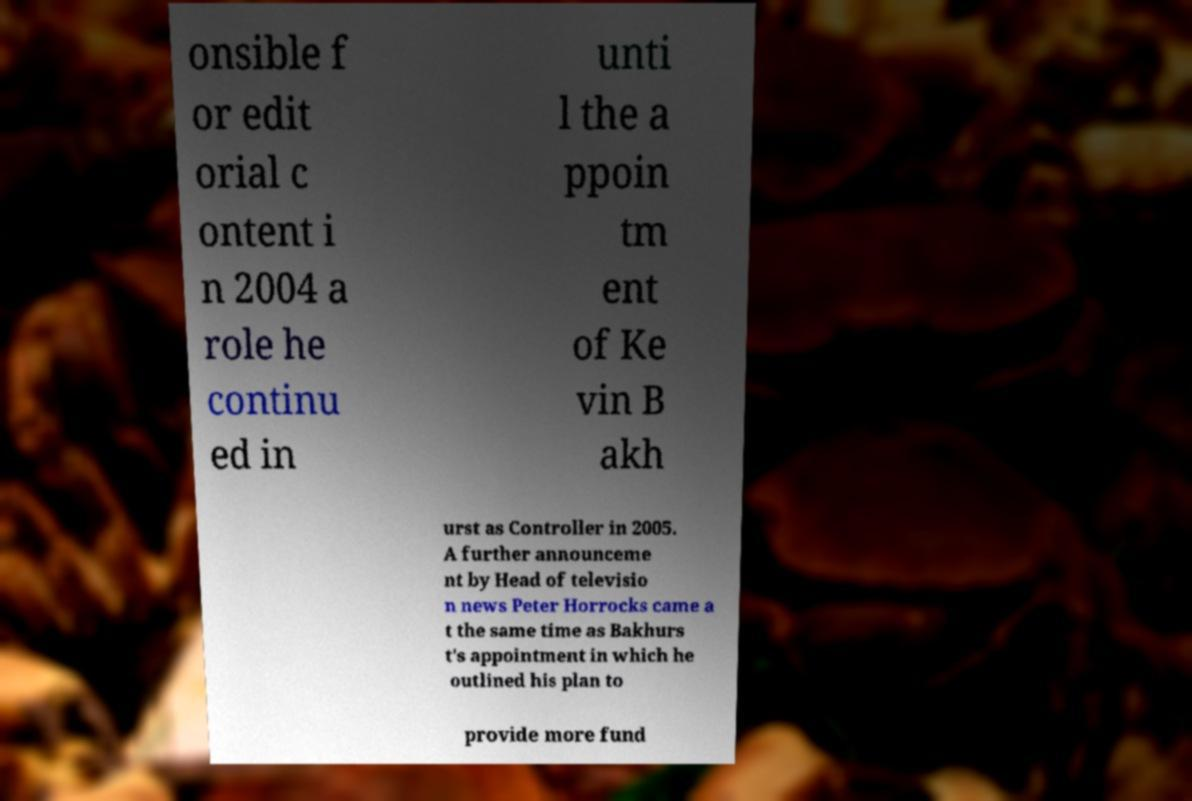Can you accurately transcribe the text from the provided image for me? onsible f or edit orial c ontent i n 2004 a role he continu ed in unti l the a ppoin tm ent of Ke vin B akh urst as Controller in 2005. A further announceme nt by Head of televisio n news Peter Horrocks came a t the same time as Bakhurs t's appointment in which he outlined his plan to provide more fund 